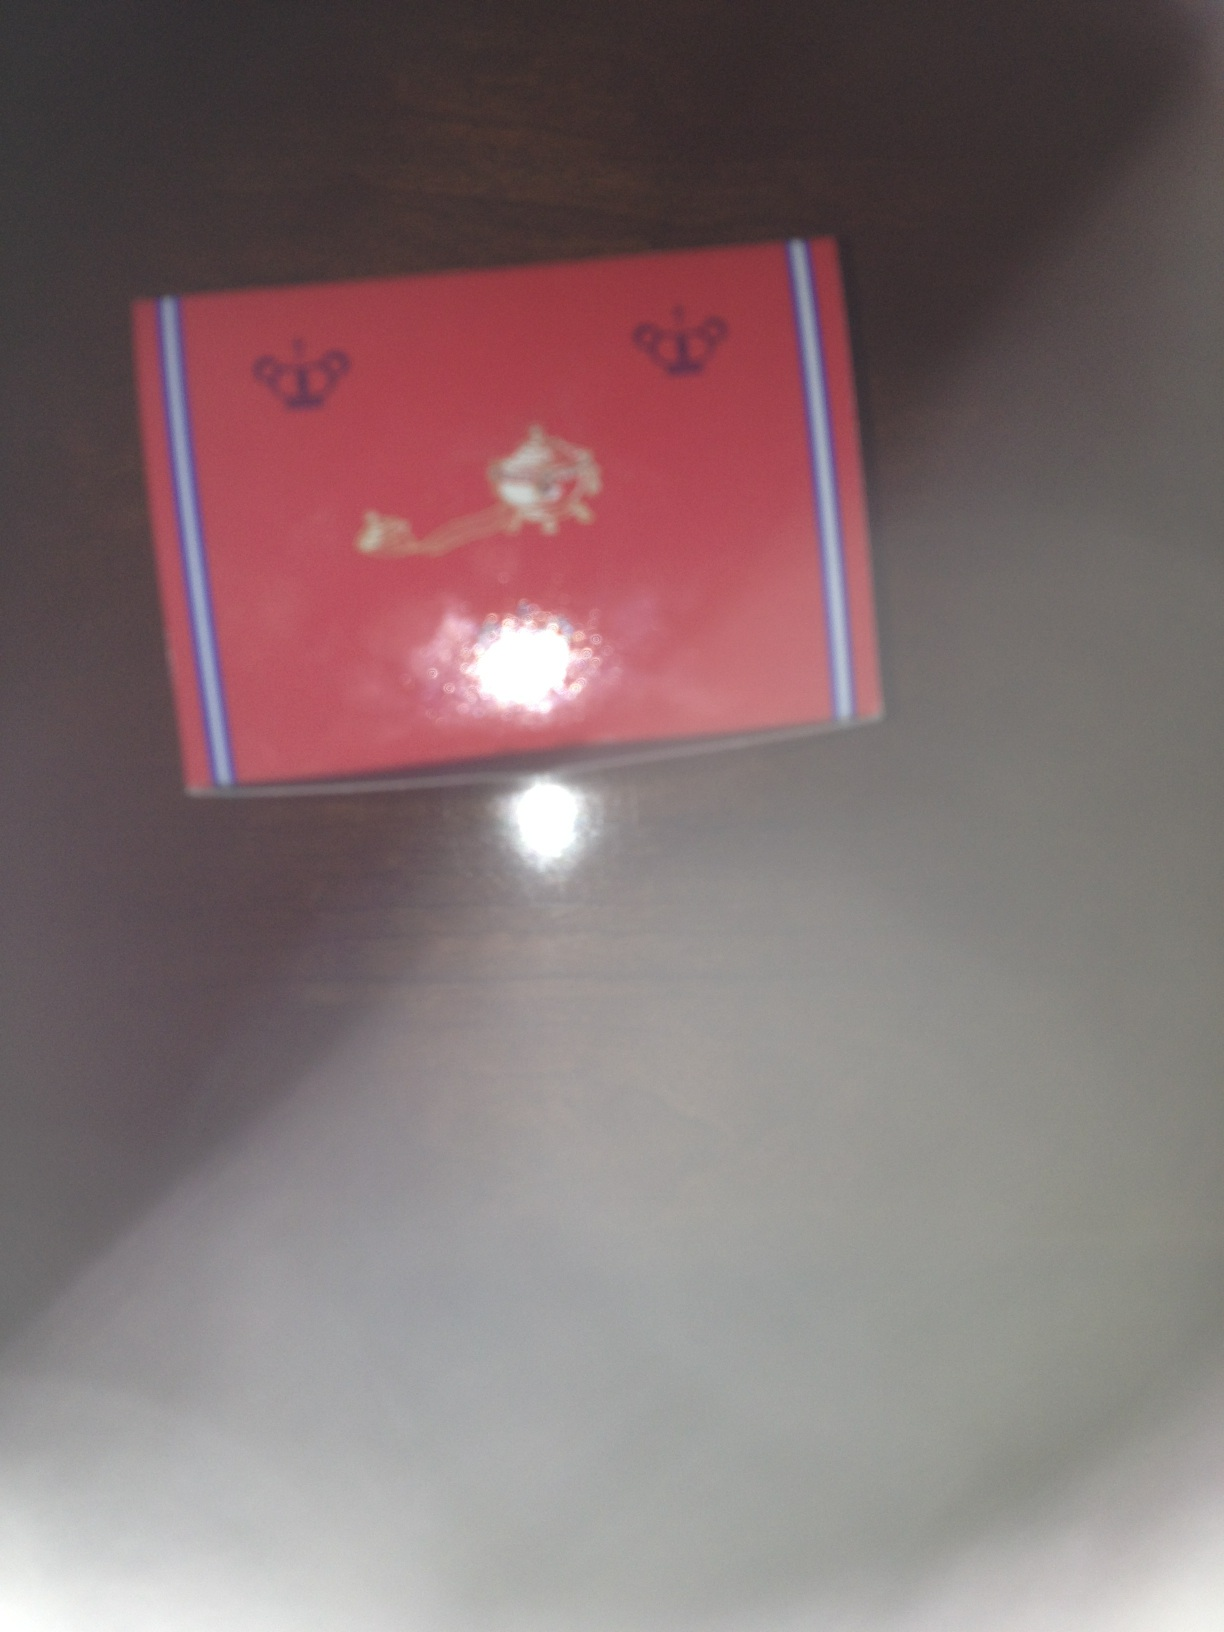What is the name of this product? Unfortunately, I am unable to determine the name of this product from the provided image. There might be some brand logos and unique designs visible, but without additional context or clearer visual elements, it's not possible to provide the exact name. If you have any more specific details or a clearer image, it would be very helpful! 